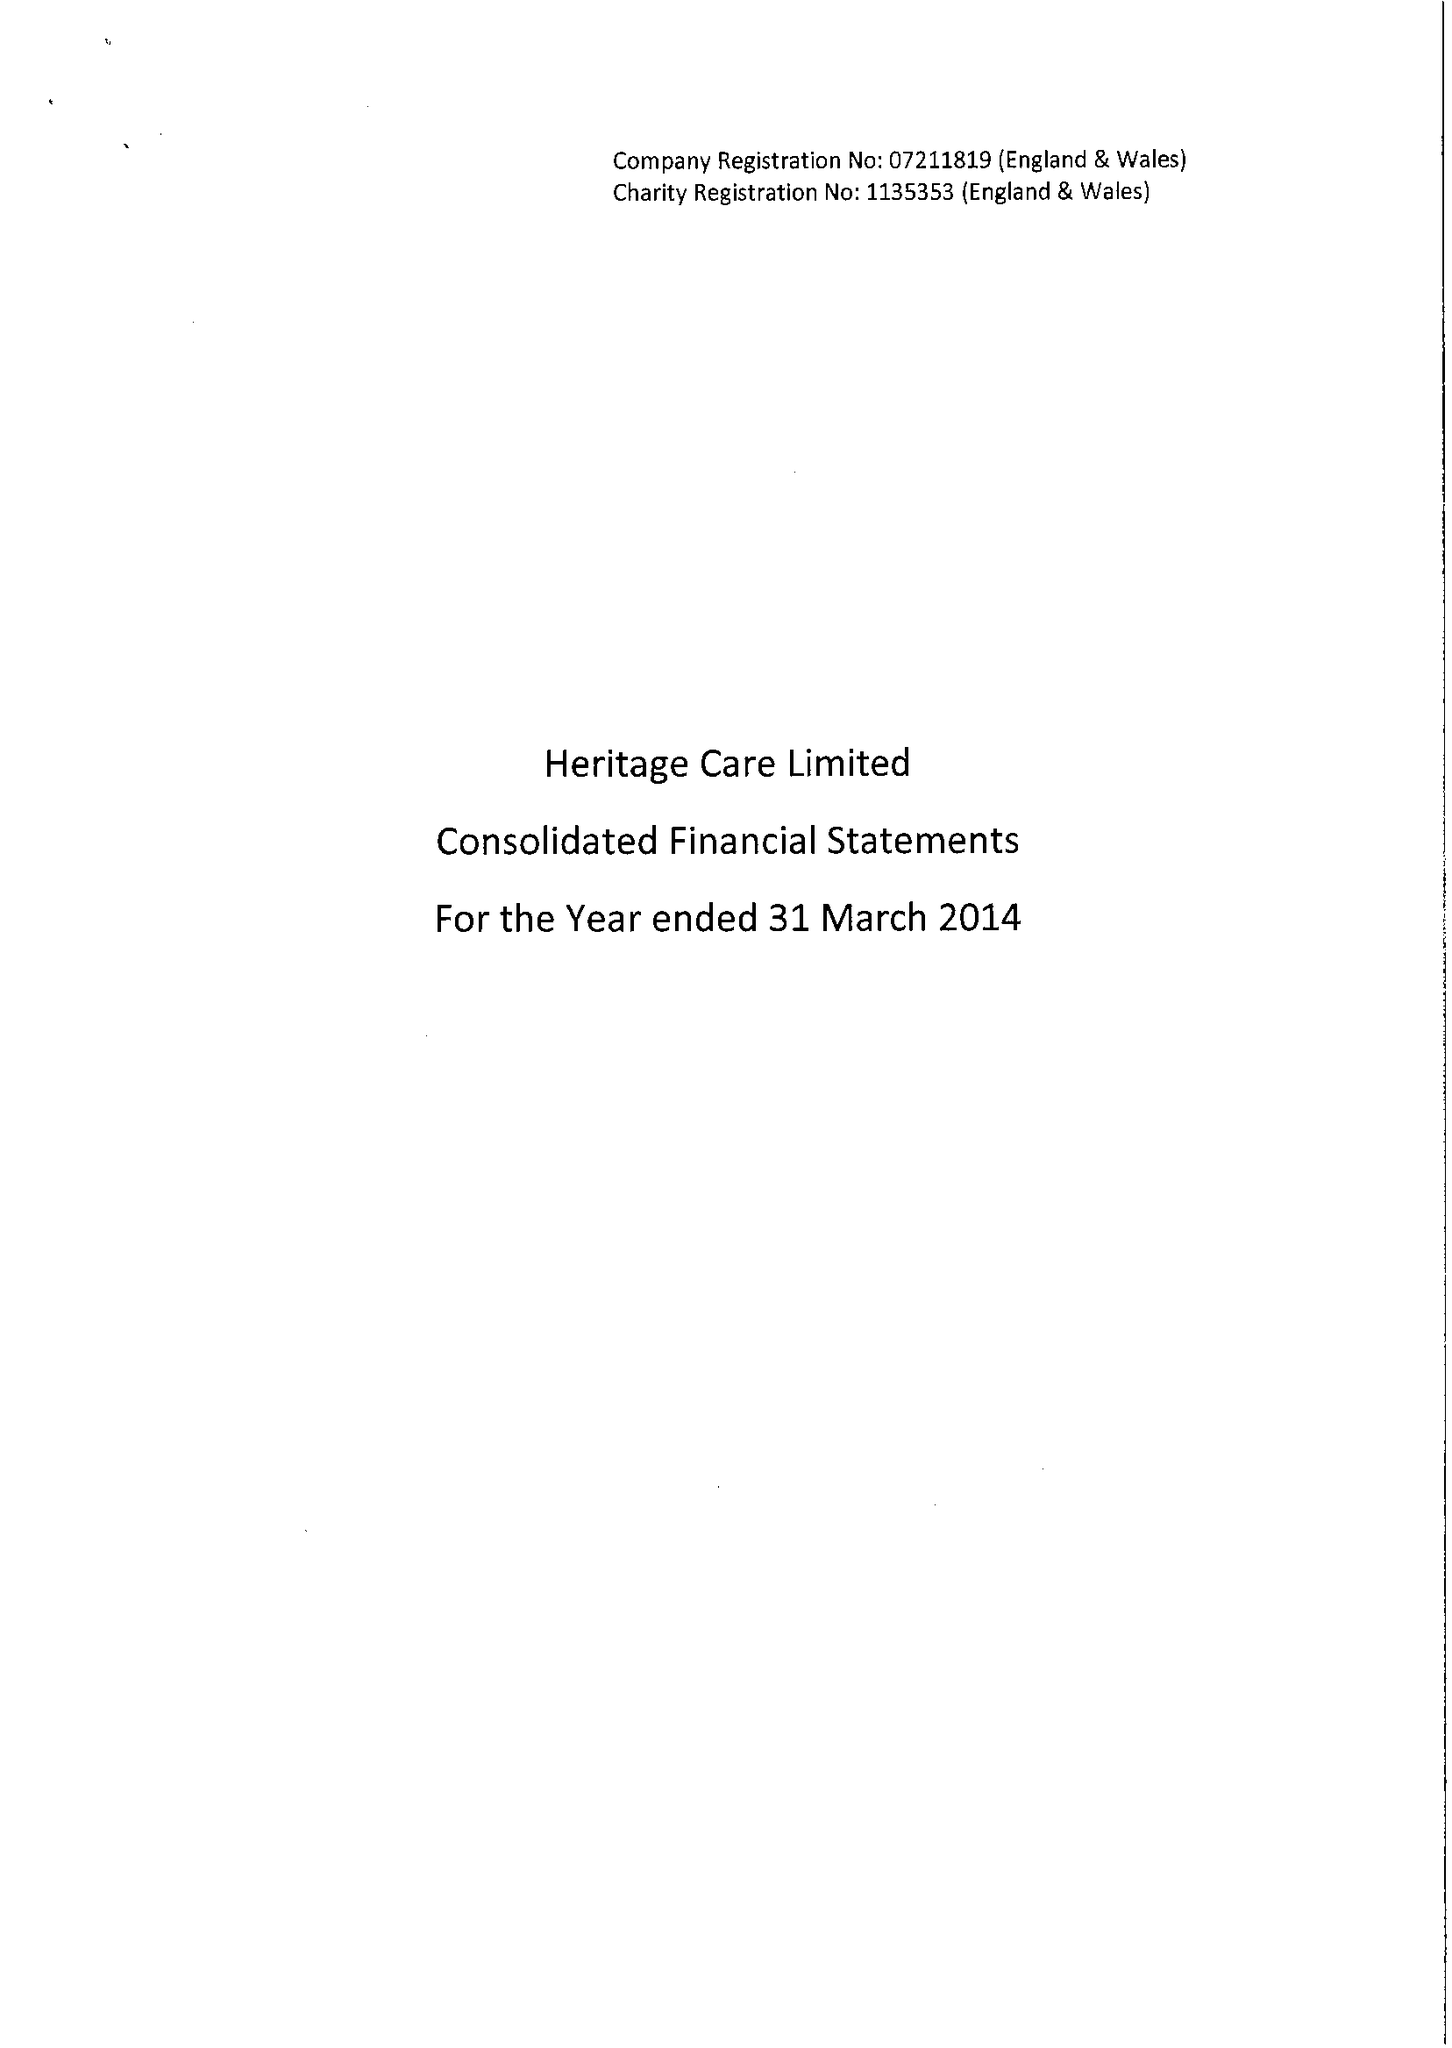What is the value for the report_date?
Answer the question using a single word or phrase. 2014-03-31 